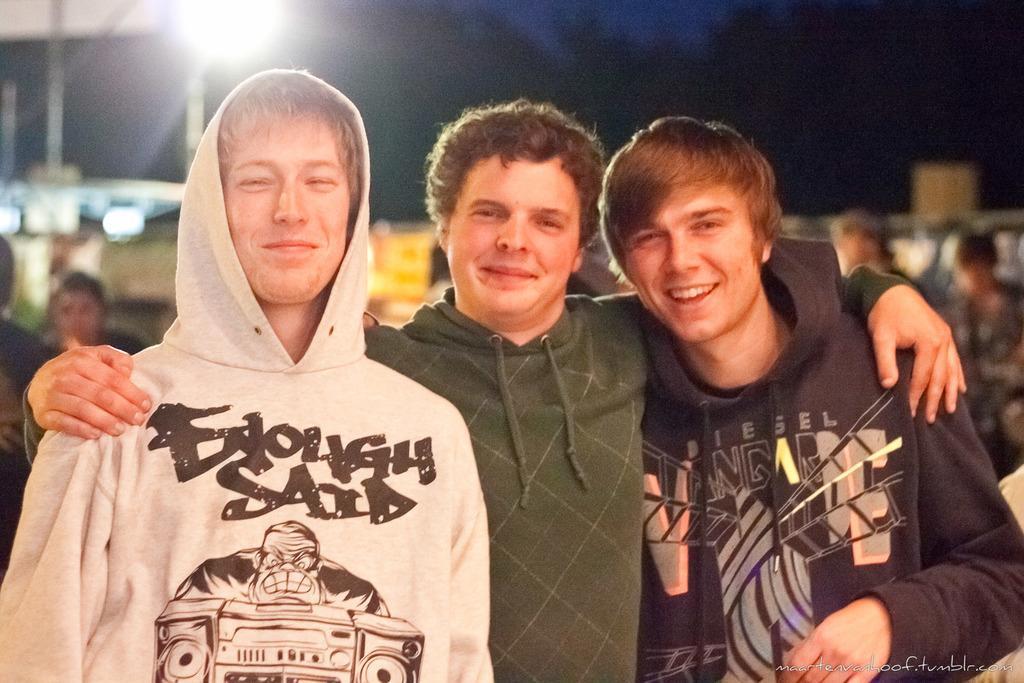In one or two sentences, can you explain what this image depicts? In this image, we can see three people are seeing and smiling. They are wearing hoodies. Background there is a blur view. Here we can see few people and light. 